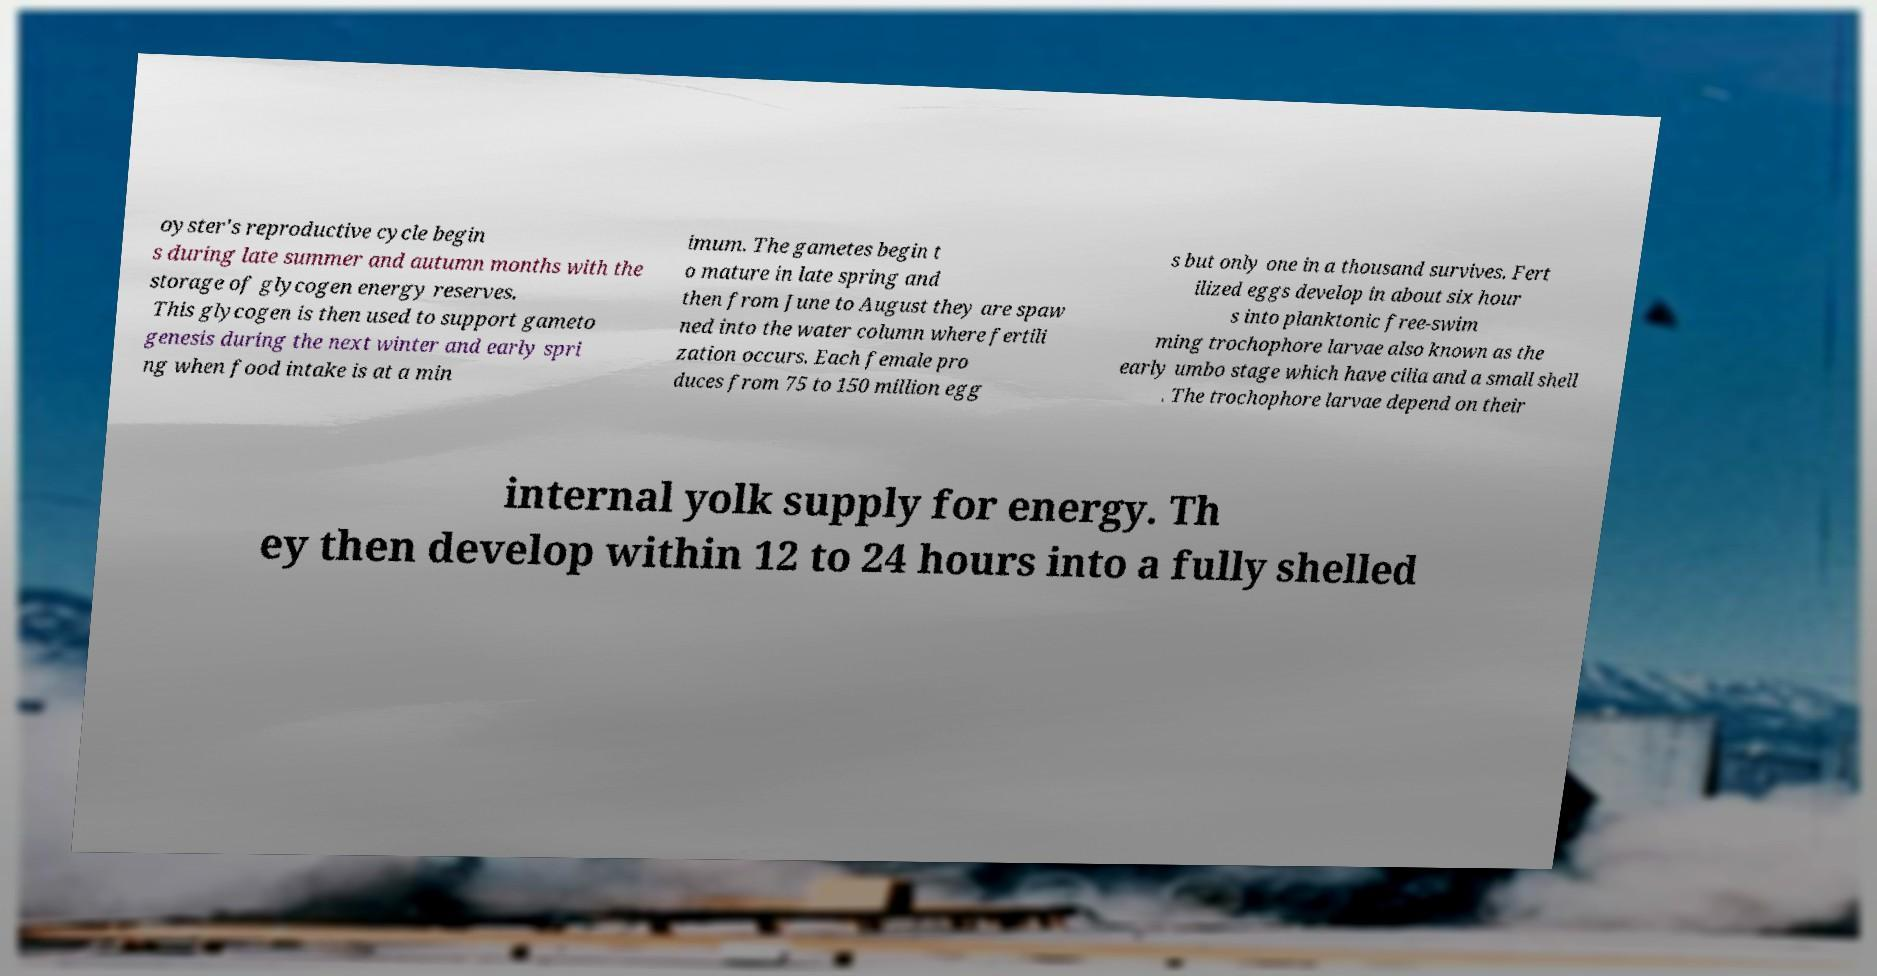Can you read and provide the text displayed in the image?This photo seems to have some interesting text. Can you extract and type it out for me? oyster's reproductive cycle begin s during late summer and autumn months with the storage of glycogen energy reserves. This glycogen is then used to support gameto genesis during the next winter and early spri ng when food intake is at a min imum. The gametes begin t o mature in late spring and then from June to August they are spaw ned into the water column where fertili zation occurs. Each female pro duces from 75 to 150 million egg s but only one in a thousand survives. Fert ilized eggs develop in about six hour s into planktonic free-swim ming trochophore larvae also known as the early umbo stage which have cilia and a small shell . The trochophore larvae depend on their internal yolk supply for energy. Th ey then develop within 12 to 24 hours into a fully shelled 